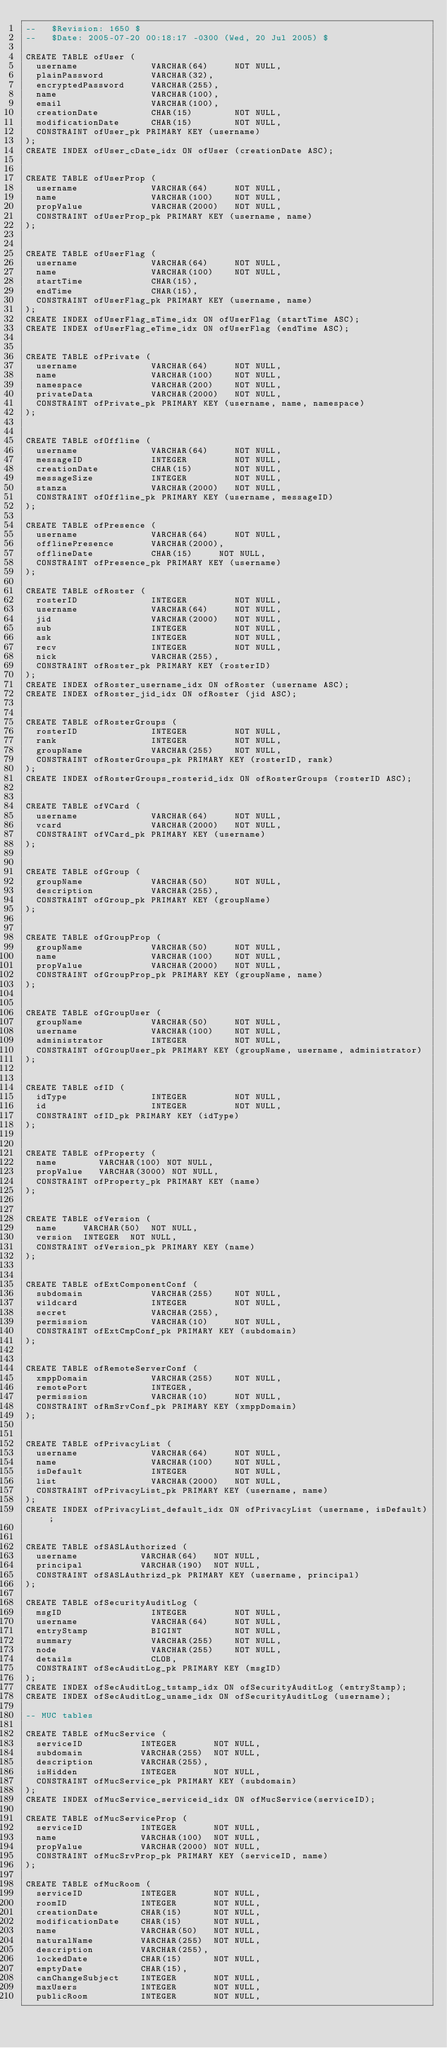<code> <loc_0><loc_0><loc_500><loc_500><_SQL_>--   $Revision: 1650 $
--   $Date: 2005-07-20 00:18:17 -0300 (Wed, 20 Jul 2005) $

CREATE TABLE ofUser (
  username              VARCHAR(64)     NOT NULL,
  plainPassword         VARCHAR(32),
  encryptedPassword     VARCHAR(255),
  name                  VARCHAR(100),
  email                 VARCHAR(100),
  creationDate          CHAR(15)        NOT NULL,
  modificationDate      CHAR(15)        NOT NULL,
  CONSTRAINT ofUser_pk PRIMARY KEY (username)
);
CREATE INDEX ofUser_cDate_idx ON ofUser (creationDate ASC);


CREATE TABLE ofUserProp (
  username              VARCHAR(64)     NOT NULL,
  name                  VARCHAR(100)    NOT NULL,
  propValue             VARCHAR(2000)   NOT NULL,
  CONSTRAINT ofUserProp_pk PRIMARY KEY (username, name)
);


CREATE TABLE ofUserFlag (
  username              VARCHAR(64)     NOT NULL,
  name                  VARCHAR(100)    NOT NULL,
  startTime             CHAR(15),
  endTime               CHAR(15),
  CONSTRAINT ofUserFlag_pk PRIMARY KEY (username, name)
);
CREATE INDEX ofUserFlag_sTime_idx ON ofUserFlag (startTime ASC);
CREATE INDEX ofUserFlag_eTime_idx ON ofUserFlag (endTime ASC);


CREATE TABLE ofPrivate (
  username              VARCHAR(64)     NOT NULL,
  name                  VARCHAR(100)    NOT NULL,
  namespace             VARCHAR(200)    NOT NULL,
  privateData           VARCHAR(2000)   NOT NULL,
  CONSTRAINT ofPrivate_pk PRIMARY KEY (username, name, namespace)
);


CREATE TABLE ofOffline (
  username              VARCHAR(64)     NOT NULL,
  messageID             INTEGER         NOT NULL,
  creationDate          CHAR(15)        NOT NULL,
  messageSize           INTEGER         NOT NULL,
  stanza                VARCHAR(2000)   NOT NULL,
  CONSTRAINT ofOffline_pk PRIMARY KEY (username, messageID)
);

CREATE TABLE ofPresence (
  username              VARCHAR(64)     NOT NULL,
  offlinePresence       VARCHAR(2000),
  offlineDate           CHAR(15)     NOT NULL,
  CONSTRAINT ofPresence_pk PRIMARY KEY (username)
);

CREATE TABLE ofRoster (
  rosterID              INTEGER         NOT NULL,
  username              VARCHAR(64)     NOT NULL,
  jid                   VARCHAR(2000)   NOT NULL,
  sub                   INTEGER         NOT NULL,
  ask                   INTEGER         NOT NULL,
  recv                  INTEGER         NOT NULL,
  nick                  VARCHAR(255),
  CONSTRAINT ofRoster_pk PRIMARY KEY (rosterID)
);
CREATE INDEX ofRoster_username_idx ON ofRoster (username ASC);
CREATE INDEX ofRoster_jid_idx ON ofRoster (jid ASC);


CREATE TABLE ofRosterGroups (
  rosterID              INTEGER         NOT NULL,
  rank                  INTEGER         NOT NULL,
  groupName             VARCHAR(255)    NOT NULL,
  CONSTRAINT ofRosterGroups_pk PRIMARY KEY (rosterID, rank)
);
CREATE INDEX ofRosterGroups_rosterid_idx ON ofRosterGroups (rosterID ASC);


CREATE TABLE ofVCard (
  username              VARCHAR(64)     NOT NULL,
  vcard                 VARCHAR(2000)   NOT NULL,
  CONSTRAINT ofVCard_pk PRIMARY KEY (username)
);


CREATE TABLE ofGroup (
  groupName             VARCHAR(50)     NOT NULL,
  description           VARCHAR(255),
  CONSTRAINT ofGroup_pk PRIMARY KEY (groupName)
);


CREATE TABLE ofGroupProp (
  groupName             VARCHAR(50)     NOT NULL,
  name                  VARCHAR(100)    NOT NULL,
  propValue             VARCHAR(2000)   NOT NULL,
  CONSTRAINT ofGroupProp_pk PRIMARY KEY (groupName, name)
);


CREATE TABLE ofGroupUser (
  groupName             VARCHAR(50)     NOT NULL,
  username              VARCHAR(100)    NOT NULL,
  administrator         INTEGER         NOT NULL,
  CONSTRAINT ofGroupUser_pk PRIMARY KEY (groupName, username, administrator)
);


CREATE TABLE ofID (
  idType                INTEGER         NOT NULL,
  id                    INTEGER         NOT NULL,
  CONSTRAINT ofID_pk PRIMARY KEY (idType)
);


CREATE TABLE ofProperty (
  name        VARCHAR(100) NOT NULL,
  propValue   VARCHAR(3000) NOT NULL,
  CONSTRAINT ofProperty_pk PRIMARY KEY (name)
);


CREATE TABLE ofVersion (
  name     VARCHAR(50)  NOT NULL,
  version  INTEGER  NOT NULL,
  CONSTRAINT ofVersion_pk PRIMARY KEY (name)
);


CREATE TABLE ofExtComponentConf (
  subdomain             VARCHAR(255)    NOT NULL,
  wildcard              INTEGER         NOT NULL,
  secret                VARCHAR(255),
  permission            VARCHAR(10)     NOT NULL,
  CONSTRAINT ofExtCmpConf_pk PRIMARY KEY (subdomain)
);


CREATE TABLE ofRemoteServerConf (
  xmppDomain            VARCHAR(255)    NOT NULL,
  remotePort            INTEGER,
  permission            VARCHAR(10)     NOT NULL,
  CONSTRAINT ofRmSrvConf_pk PRIMARY KEY (xmppDomain)
);


CREATE TABLE ofPrivacyList (
  username              VARCHAR(64)     NOT NULL,
  name                  VARCHAR(100)    NOT NULL,
  isDefault             INTEGER         NOT NULL,
  list                  VARCHAR(2000)   NOT NULL,
  CONSTRAINT ofPrivacyList_pk PRIMARY KEY (username, name)
);
CREATE INDEX ofPrivacyList_default_idx ON ofPrivacyList (username, isDefault);


CREATE TABLE ofSASLAuthorized (
  username            VARCHAR(64)   NOT NULL,
  principal           VARCHAR(190)  NOT NULL,
  CONSTRAINT ofSASLAuthrizd_pk PRIMARY KEY (username, principal)
);

CREATE TABLE ofSecurityAuditLog (
  msgID                 INTEGER         NOT NULL,
  username              VARCHAR(64)     NOT NULL,
  entryStamp            BIGINT          NOT NULL,
  summary               VARCHAR(255)    NOT NULL,
  node                  VARCHAR(255)    NOT NULL,
  details               CLOB,
  CONSTRAINT ofSecAuditLog_pk PRIMARY KEY (msgID)
);
CREATE INDEX ofSecAuditLog_tstamp_idx ON ofSecurityAuditLog (entryStamp);
CREATE INDEX ofSecAuditLog_uname_idx ON ofSecurityAuditLog (username);

-- MUC tables

CREATE TABLE ofMucService (
  serviceID           INTEGER       NOT NULL,
  subdomain           VARCHAR(255)  NOT NULL,
  description         VARCHAR(255),
  isHidden            INTEGER       NOT NULL,
  CONSTRAINT ofMucService_pk PRIMARY KEY (subdomain)
);
CREATE INDEX ofMucService_serviceid_idx ON ofMucService(serviceID);

CREATE TABLE ofMucServiceProp (
  serviceID           INTEGER       NOT NULL,
  name                VARCHAR(100)  NOT NULL,
  propValue           VARCHAR(2000) NOT NULL,
  CONSTRAINT ofMucSrvProp_pk PRIMARY KEY (serviceID, name)
);

CREATE TABLE ofMucRoom (
  serviceID           INTEGER       NOT NULL,
  roomID              INTEGER       NOT NULL,
  creationDate        CHAR(15)      NOT NULL,
  modificationDate    CHAR(15)      NOT NULL,
  name                VARCHAR(50)   NOT NULL,
  naturalName         VARCHAR(255)  NOT NULL,
  description         VARCHAR(255),
  lockedDate          CHAR(15)      NOT NULL,
  emptyDate           CHAR(15),
  canChangeSubject    INTEGER       NOT NULL,
  maxUsers            INTEGER       NOT NULL,
  publicRoom          INTEGER       NOT NULL,</code> 